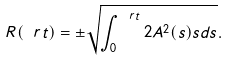<formula> <loc_0><loc_0><loc_500><loc_500>R ( \ r t ) = \pm \sqrt { \int _ { 0 } ^ { \ r t } 2 A ^ { 2 } ( s ) s d s } .</formula> 